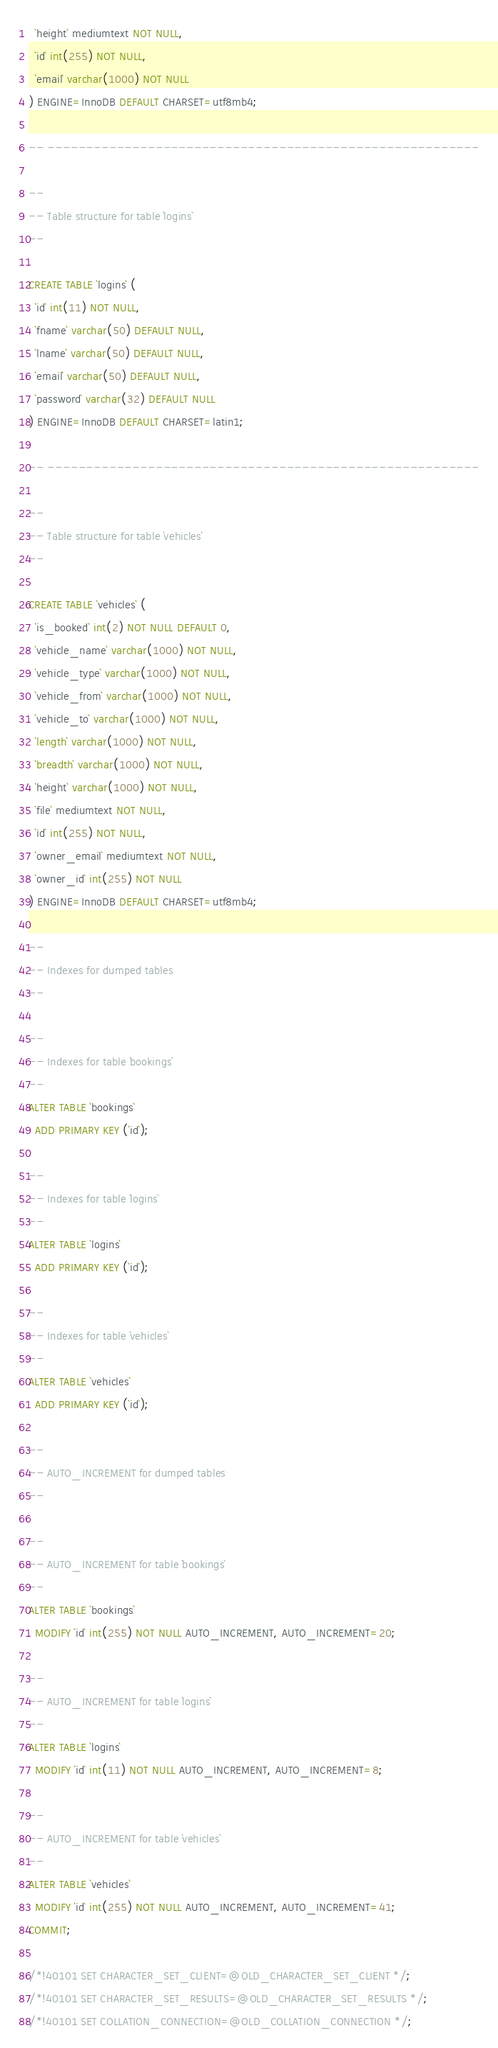<code> <loc_0><loc_0><loc_500><loc_500><_SQL_>  `height` mediumtext NOT NULL,
  `id` int(255) NOT NULL,
  `email` varchar(1000) NOT NULL
) ENGINE=InnoDB DEFAULT CHARSET=utf8mb4;

-- --------------------------------------------------------

--
-- Table structure for table `logins`
--

CREATE TABLE `logins` (
  `id` int(11) NOT NULL,
  `fname` varchar(50) DEFAULT NULL,
  `lname` varchar(50) DEFAULT NULL,
  `email` varchar(50) DEFAULT NULL,
  `password` varchar(32) DEFAULT NULL
) ENGINE=InnoDB DEFAULT CHARSET=latin1;

-- --------------------------------------------------------

--
-- Table structure for table `vehicles`
--

CREATE TABLE `vehicles` (
  `is_booked` int(2) NOT NULL DEFAULT 0,
  `vehicle_name` varchar(1000) NOT NULL,
  `vehicle_type` varchar(1000) NOT NULL,
  `vehicle_from` varchar(1000) NOT NULL,
  `vehicle_to` varchar(1000) NOT NULL,
  `length` varchar(1000) NOT NULL,
  `breadth` varchar(1000) NOT NULL,
  `height` varchar(1000) NOT NULL,
  `file` mediumtext NOT NULL,
  `id` int(255) NOT NULL,
  `owner_email` mediumtext NOT NULL,
  `owner_id` int(255) NOT NULL
) ENGINE=InnoDB DEFAULT CHARSET=utf8mb4;

--
-- Indexes for dumped tables
--

--
-- Indexes for table `bookings`
--
ALTER TABLE `bookings`
  ADD PRIMARY KEY (`id`);

--
-- Indexes for table `logins`
--
ALTER TABLE `logins`
  ADD PRIMARY KEY (`id`);

--
-- Indexes for table `vehicles`
--
ALTER TABLE `vehicles`
  ADD PRIMARY KEY (`id`);

--
-- AUTO_INCREMENT for dumped tables
--

--
-- AUTO_INCREMENT for table `bookings`
--
ALTER TABLE `bookings`
  MODIFY `id` int(255) NOT NULL AUTO_INCREMENT, AUTO_INCREMENT=20;

--
-- AUTO_INCREMENT for table `logins`
--
ALTER TABLE `logins`
  MODIFY `id` int(11) NOT NULL AUTO_INCREMENT, AUTO_INCREMENT=8;

--
-- AUTO_INCREMENT for table `vehicles`
--
ALTER TABLE `vehicles`
  MODIFY `id` int(255) NOT NULL AUTO_INCREMENT, AUTO_INCREMENT=41;
COMMIT;

/*!40101 SET CHARACTER_SET_CLIENT=@OLD_CHARACTER_SET_CLIENT */;
/*!40101 SET CHARACTER_SET_RESULTS=@OLD_CHARACTER_SET_RESULTS */;
/*!40101 SET COLLATION_CONNECTION=@OLD_COLLATION_CONNECTION */;
</code> 